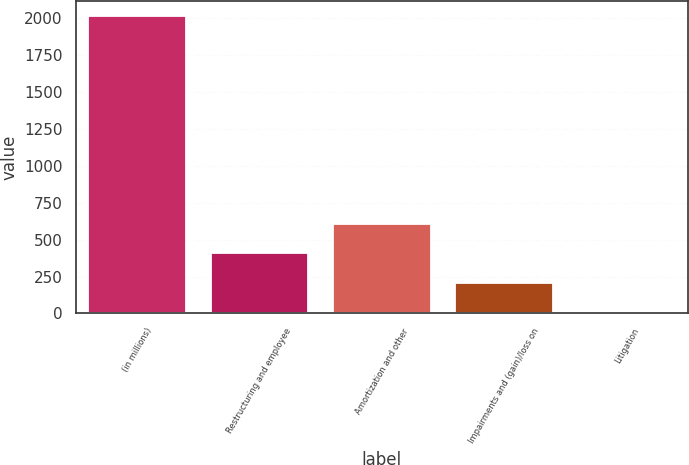Convert chart. <chart><loc_0><loc_0><loc_500><loc_500><bar_chart><fcel>(in millions)<fcel>Restructuring and employee<fcel>Amortization and other<fcel>Impairments and (gain)/loss on<fcel>Litigation<nl><fcel>2015<fcel>407<fcel>608<fcel>206<fcel>5<nl></chart> 